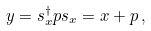Convert formula to latex. <formula><loc_0><loc_0><loc_500><loc_500>y = s _ { x } ^ { \dagger } p s _ { x } = x + p \, ,</formula> 